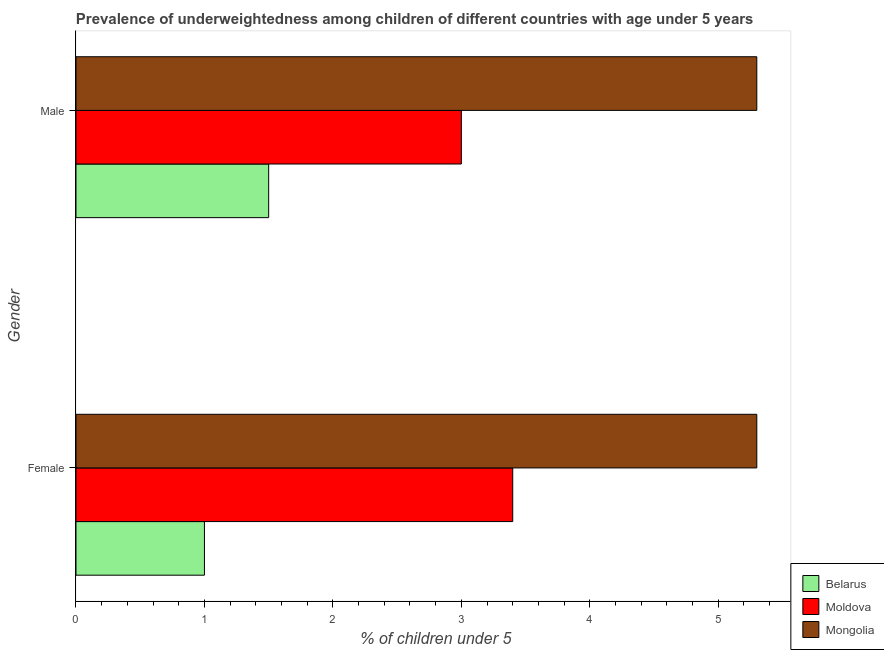How many different coloured bars are there?
Your answer should be very brief. 3. Are the number of bars per tick equal to the number of legend labels?
Your answer should be very brief. Yes. What is the percentage of underweighted female children in Belarus?
Keep it short and to the point. 1. Across all countries, what is the maximum percentage of underweighted female children?
Ensure brevity in your answer.  5.3. In which country was the percentage of underweighted female children maximum?
Provide a short and direct response. Mongolia. In which country was the percentage of underweighted male children minimum?
Offer a very short reply. Belarus. What is the total percentage of underweighted female children in the graph?
Make the answer very short. 9.7. What is the difference between the percentage of underweighted female children in Belarus and that in Moldova?
Provide a short and direct response. -2.4. What is the difference between the percentage of underweighted male children in Mongolia and the percentage of underweighted female children in Belarus?
Your response must be concise. 4.3. What is the average percentage of underweighted female children per country?
Your answer should be compact. 3.23. What is the difference between the percentage of underweighted female children and percentage of underweighted male children in Moldova?
Your answer should be very brief. 0.4. In how many countries, is the percentage of underweighted female children greater than 3.6 %?
Ensure brevity in your answer.  1. What is the ratio of the percentage of underweighted male children in Moldova to that in Mongolia?
Your answer should be very brief. 0.57. Is the percentage of underweighted male children in Mongolia less than that in Belarus?
Keep it short and to the point. No. In how many countries, is the percentage of underweighted female children greater than the average percentage of underweighted female children taken over all countries?
Ensure brevity in your answer.  2. What does the 2nd bar from the top in Male represents?
Offer a terse response. Moldova. What does the 2nd bar from the bottom in Female represents?
Make the answer very short. Moldova. Are the values on the major ticks of X-axis written in scientific E-notation?
Make the answer very short. No. Does the graph contain grids?
Your response must be concise. No. Where does the legend appear in the graph?
Offer a very short reply. Bottom right. How many legend labels are there?
Your response must be concise. 3. How are the legend labels stacked?
Make the answer very short. Vertical. What is the title of the graph?
Your answer should be compact. Prevalence of underweightedness among children of different countries with age under 5 years. What is the label or title of the X-axis?
Provide a succinct answer.  % of children under 5. What is the label or title of the Y-axis?
Your response must be concise. Gender. What is the  % of children under 5 of Belarus in Female?
Keep it short and to the point. 1. What is the  % of children under 5 in Moldova in Female?
Give a very brief answer. 3.4. What is the  % of children under 5 of Mongolia in Female?
Give a very brief answer. 5.3. What is the  % of children under 5 of Belarus in Male?
Offer a terse response. 1.5. What is the  % of children under 5 of Mongolia in Male?
Your answer should be very brief. 5.3. Across all Gender, what is the maximum  % of children under 5 of Moldova?
Ensure brevity in your answer.  3.4. Across all Gender, what is the maximum  % of children under 5 in Mongolia?
Keep it short and to the point. 5.3. Across all Gender, what is the minimum  % of children under 5 in Belarus?
Your response must be concise. 1. Across all Gender, what is the minimum  % of children under 5 in Moldova?
Make the answer very short. 3. Across all Gender, what is the minimum  % of children under 5 of Mongolia?
Give a very brief answer. 5.3. What is the total  % of children under 5 in Belarus in the graph?
Provide a short and direct response. 2.5. What is the difference between the  % of children under 5 in Moldova in Female and the  % of children under 5 in Mongolia in Male?
Make the answer very short. -1.9. What is the difference between the  % of children under 5 of Moldova and  % of children under 5 of Mongolia in Male?
Your answer should be very brief. -2.3. What is the ratio of the  % of children under 5 of Moldova in Female to that in Male?
Provide a short and direct response. 1.13. What is the ratio of the  % of children under 5 of Mongolia in Female to that in Male?
Make the answer very short. 1. What is the difference between the highest and the second highest  % of children under 5 of Mongolia?
Provide a short and direct response. 0. What is the difference between the highest and the lowest  % of children under 5 of Moldova?
Your response must be concise. 0.4. What is the difference between the highest and the lowest  % of children under 5 of Mongolia?
Offer a terse response. 0. 